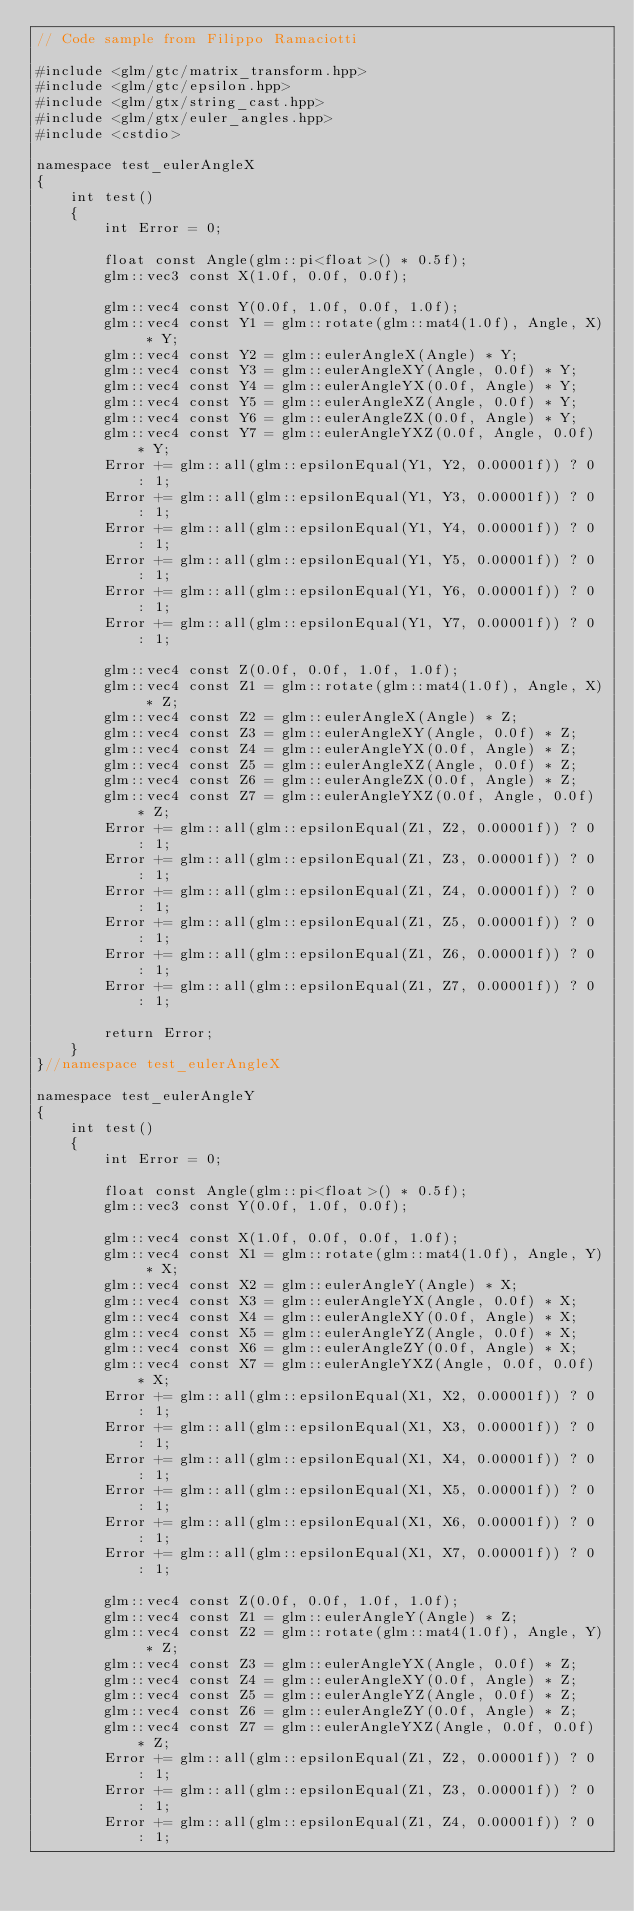<code> <loc_0><loc_0><loc_500><loc_500><_C++_>// Code sample from Filippo Ramaciotti

#include <glm/gtc/matrix_transform.hpp>
#include <glm/gtc/epsilon.hpp>
#include <glm/gtx/string_cast.hpp>
#include <glm/gtx/euler_angles.hpp>
#include <cstdio>

namespace test_eulerAngleX
{
	int test()
	{
		int Error = 0;

		float const Angle(glm::pi<float>() * 0.5f);
		glm::vec3 const X(1.0f, 0.0f, 0.0f);

		glm::vec4 const Y(0.0f, 1.0f, 0.0f, 1.0f);
		glm::vec4 const Y1 = glm::rotate(glm::mat4(1.0f), Angle, X) * Y;
		glm::vec4 const Y2 = glm::eulerAngleX(Angle) * Y;
		glm::vec4 const Y3 = glm::eulerAngleXY(Angle, 0.0f) * Y;
		glm::vec4 const Y4 = glm::eulerAngleYX(0.0f, Angle) * Y;
		glm::vec4 const Y5 = glm::eulerAngleXZ(Angle, 0.0f) * Y;
		glm::vec4 const Y6 = glm::eulerAngleZX(0.0f, Angle) * Y;
		glm::vec4 const Y7 = glm::eulerAngleYXZ(0.0f, Angle, 0.0f) * Y;
		Error += glm::all(glm::epsilonEqual(Y1, Y2, 0.00001f)) ? 0 : 1;
		Error += glm::all(glm::epsilonEqual(Y1, Y3, 0.00001f)) ? 0 : 1;
		Error += glm::all(glm::epsilonEqual(Y1, Y4, 0.00001f)) ? 0 : 1;
		Error += glm::all(glm::epsilonEqual(Y1, Y5, 0.00001f)) ? 0 : 1;
		Error += glm::all(glm::epsilonEqual(Y1, Y6, 0.00001f)) ? 0 : 1;
		Error += glm::all(glm::epsilonEqual(Y1, Y7, 0.00001f)) ? 0 : 1;

		glm::vec4 const Z(0.0f, 0.0f, 1.0f, 1.0f);
		glm::vec4 const Z1 = glm::rotate(glm::mat4(1.0f), Angle, X) * Z;
		glm::vec4 const Z2 = glm::eulerAngleX(Angle) * Z;
		glm::vec4 const Z3 = glm::eulerAngleXY(Angle, 0.0f) * Z;
		glm::vec4 const Z4 = glm::eulerAngleYX(0.0f, Angle) * Z;
		glm::vec4 const Z5 = glm::eulerAngleXZ(Angle, 0.0f) * Z;
		glm::vec4 const Z6 = glm::eulerAngleZX(0.0f, Angle) * Z;
		glm::vec4 const Z7 = glm::eulerAngleYXZ(0.0f, Angle, 0.0f) * Z;
		Error += glm::all(glm::epsilonEqual(Z1, Z2, 0.00001f)) ? 0 : 1;
		Error += glm::all(glm::epsilonEqual(Z1, Z3, 0.00001f)) ? 0 : 1;
		Error += glm::all(glm::epsilonEqual(Z1, Z4, 0.00001f)) ? 0 : 1;
		Error += glm::all(glm::epsilonEqual(Z1, Z5, 0.00001f)) ? 0 : 1;
		Error += glm::all(glm::epsilonEqual(Z1, Z6, 0.00001f)) ? 0 : 1;
		Error += glm::all(glm::epsilonEqual(Z1, Z7, 0.00001f)) ? 0 : 1;

		return Error;
	}
}//namespace test_eulerAngleX

namespace test_eulerAngleY
{
	int test()
	{
		int Error = 0;

		float const Angle(glm::pi<float>() * 0.5f);
		glm::vec3 const Y(0.0f, 1.0f, 0.0f);

		glm::vec4 const X(1.0f, 0.0f, 0.0f, 1.0f);
		glm::vec4 const X1 = glm::rotate(glm::mat4(1.0f), Angle, Y) * X;
		glm::vec4 const X2 = glm::eulerAngleY(Angle) * X;
		glm::vec4 const X3 = glm::eulerAngleYX(Angle, 0.0f) * X;
		glm::vec4 const X4 = glm::eulerAngleXY(0.0f, Angle) * X;
		glm::vec4 const X5 = glm::eulerAngleYZ(Angle, 0.0f) * X;
		glm::vec4 const X6 = glm::eulerAngleZY(0.0f, Angle) * X;
		glm::vec4 const X7 = glm::eulerAngleYXZ(Angle, 0.0f, 0.0f) * X;
		Error += glm::all(glm::epsilonEqual(X1, X2, 0.00001f)) ? 0 : 1;
		Error += glm::all(glm::epsilonEqual(X1, X3, 0.00001f)) ? 0 : 1;
		Error += glm::all(glm::epsilonEqual(X1, X4, 0.00001f)) ? 0 : 1;
		Error += glm::all(glm::epsilonEqual(X1, X5, 0.00001f)) ? 0 : 1;
		Error += glm::all(glm::epsilonEqual(X1, X6, 0.00001f)) ? 0 : 1;
		Error += glm::all(glm::epsilonEqual(X1, X7, 0.00001f)) ? 0 : 1;

		glm::vec4 const Z(0.0f, 0.0f, 1.0f, 1.0f);
		glm::vec4 const Z1 = glm::eulerAngleY(Angle) * Z;
		glm::vec4 const Z2 = glm::rotate(glm::mat4(1.0f), Angle, Y) * Z;
		glm::vec4 const Z3 = glm::eulerAngleYX(Angle, 0.0f) * Z;
		glm::vec4 const Z4 = glm::eulerAngleXY(0.0f, Angle) * Z;
		glm::vec4 const Z5 = glm::eulerAngleYZ(Angle, 0.0f) * Z;
		glm::vec4 const Z6 = glm::eulerAngleZY(0.0f, Angle) * Z;
		glm::vec4 const Z7 = glm::eulerAngleYXZ(Angle, 0.0f, 0.0f) * Z;
		Error += glm::all(glm::epsilonEqual(Z1, Z2, 0.00001f)) ? 0 : 1;
		Error += glm::all(glm::epsilonEqual(Z1, Z3, 0.00001f)) ? 0 : 1;
		Error += glm::all(glm::epsilonEqual(Z1, Z4, 0.00001f)) ? 0 : 1;</code> 